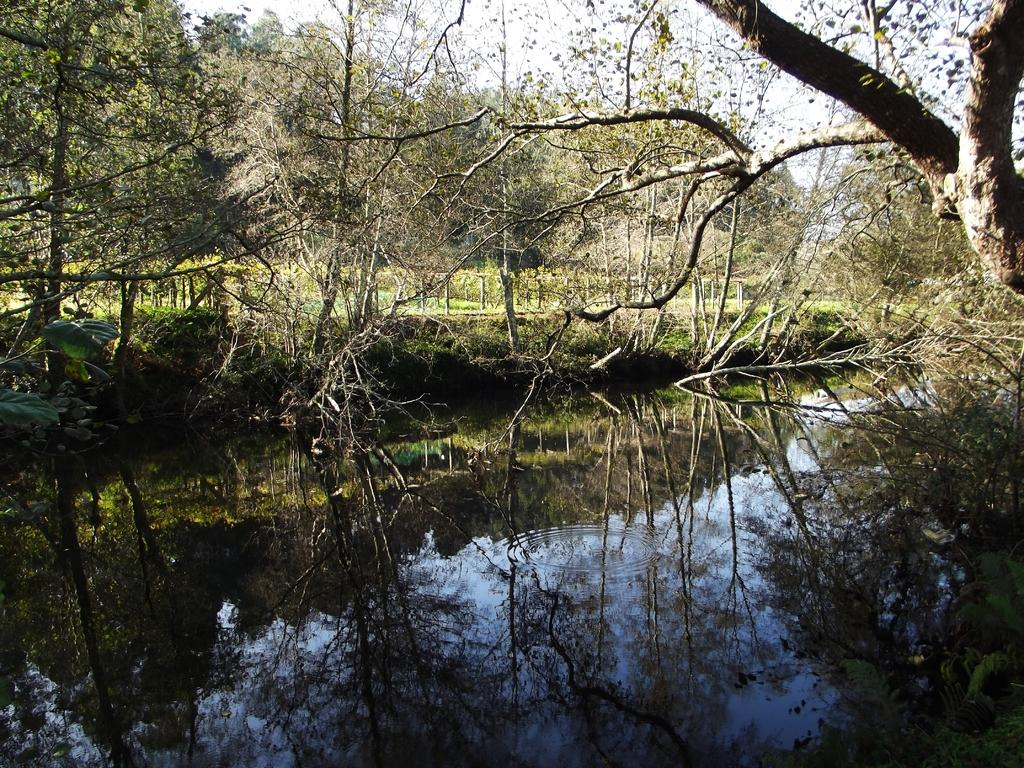What type of vegetation can be seen in the image? There are trees in the image. What else can be seen on the ground in the image? There is grass in the image. What part of the natural environment is visible in the image? The sky is visible in the image. Can you identify any bodies of water in the image? Yes, there is water in the image, as evidenced by the reflection of trees. How many items are on the list in the image? There is no list present in the image. What is the stomach size of the tree in the image? There is no tree with a stomach in the image; trees do not have stomachs. 